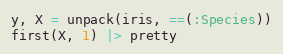Convert code to text. <code><loc_0><loc_0><loc_500><loc_500><_Julia_>y, X = unpack(iris, ==(:Species))
first(X, 1) |> pretty</code> 